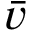Convert formula to latex. <formula><loc_0><loc_0><loc_500><loc_500>\bar { v }</formula> 